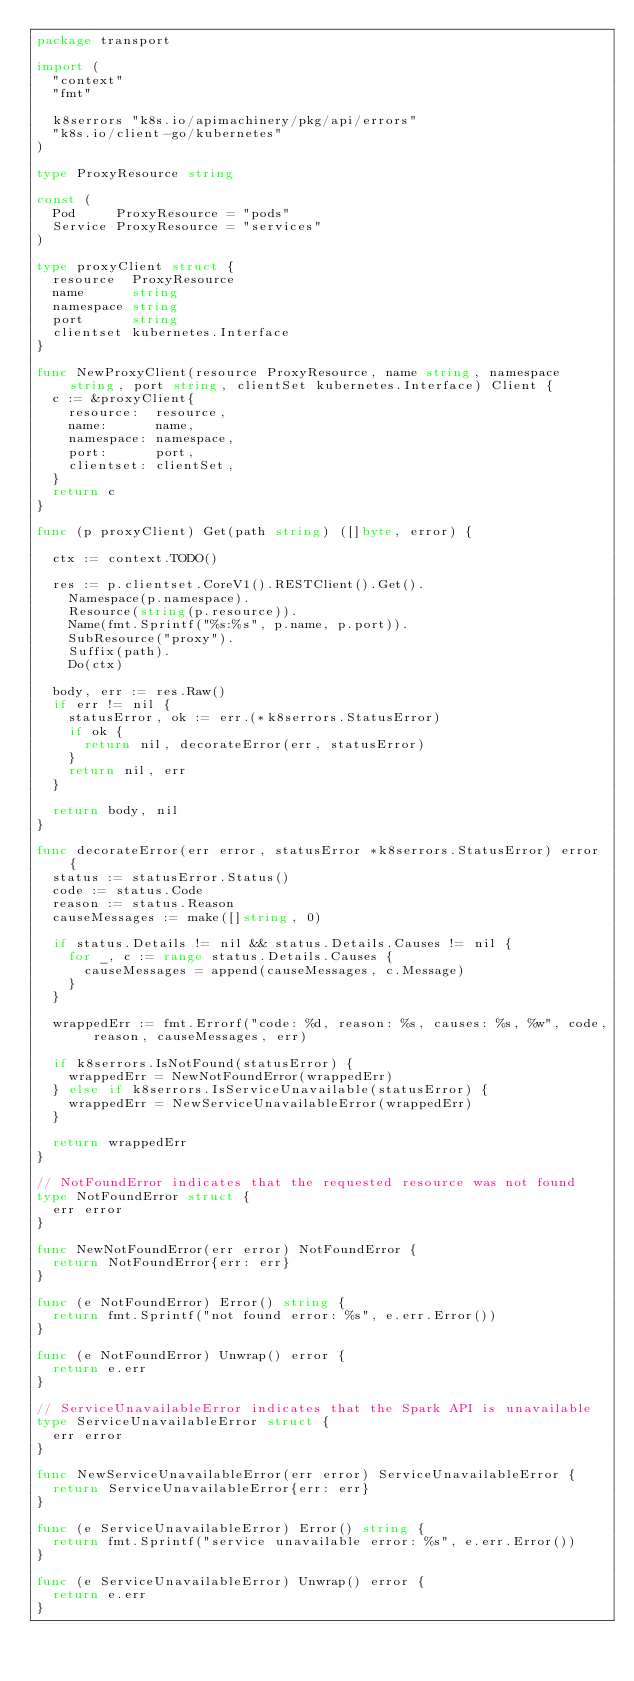Convert code to text. <code><loc_0><loc_0><loc_500><loc_500><_Go_>package transport

import (
	"context"
	"fmt"

	k8serrors "k8s.io/apimachinery/pkg/api/errors"
	"k8s.io/client-go/kubernetes"
)

type ProxyResource string

const (
	Pod     ProxyResource = "pods"
	Service ProxyResource = "services"
)

type proxyClient struct {
	resource  ProxyResource
	name      string
	namespace string
	port      string
	clientset kubernetes.Interface
}

func NewProxyClient(resource ProxyResource, name string, namespace string, port string, clientSet kubernetes.Interface) Client {
	c := &proxyClient{
		resource:  resource,
		name:      name,
		namespace: namespace,
		port:      port,
		clientset: clientSet,
	}
	return c
}

func (p proxyClient) Get(path string) ([]byte, error) {

	ctx := context.TODO()

	res := p.clientset.CoreV1().RESTClient().Get().
		Namespace(p.namespace).
		Resource(string(p.resource)).
		Name(fmt.Sprintf("%s:%s", p.name, p.port)).
		SubResource("proxy").
		Suffix(path).
		Do(ctx)

	body, err := res.Raw()
	if err != nil {
		statusError, ok := err.(*k8serrors.StatusError)
		if ok {
			return nil, decorateError(err, statusError)
		}
		return nil, err
	}

	return body, nil
}

func decorateError(err error, statusError *k8serrors.StatusError) error {
	status := statusError.Status()
	code := status.Code
	reason := status.Reason
	causeMessages := make([]string, 0)

	if status.Details != nil && status.Details.Causes != nil {
		for _, c := range status.Details.Causes {
			causeMessages = append(causeMessages, c.Message)
		}
	}

	wrappedErr := fmt.Errorf("code: %d, reason: %s, causes: %s, %w", code, reason, causeMessages, err)

	if k8serrors.IsNotFound(statusError) {
		wrappedErr = NewNotFoundError(wrappedErr)
	} else if k8serrors.IsServiceUnavailable(statusError) {
		wrappedErr = NewServiceUnavailableError(wrappedErr)
	}

	return wrappedErr
}

// NotFoundError indicates that the requested resource was not found
type NotFoundError struct {
	err error
}

func NewNotFoundError(err error) NotFoundError {
	return NotFoundError{err: err}
}

func (e NotFoundError) Error() string {
	return fmt.Sprintf("not found error: %s", e.err.Error())
}

func (e NotFoundError) Unwrap() error {
	return e.err
}

// ServiceUnavailableError indicates that the Spark API is unavailable
type ServiceUnavailableError struct {
	err error
}

func NewServiceUnavailableError(err error) ServiceUnavailableError {
	return ServiceUnavailableError{err: err}
}

func (e ServiceUnavailableError) Error() string {
	return fmt.Sprintf("service unavailable error: %s", e.err.Error())
}

func (e ServiceUnavailableError) Unwrap() error {
	return e.err
}
</code> 